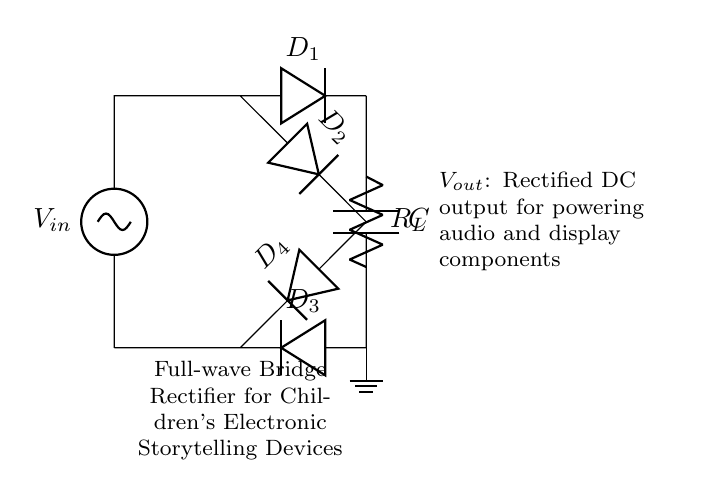What is the type of rectifier used in this circuit? The circuit uses a full-wave bridge rectifier, which is evident from the arrangement of four diodes configured to allow both halves of the AC waveform to contribute to the output.
Answer: full-wave bridge rectifier How many diodes are present in this circuit? There are four diodes in the circuit, labeled as D1, D2, D3, and D4, all crucial for the full-wave rectification process.
Answer: four What is the role of the capacitor in this circuit? The capacitor, labeled as C, is used for smoothing the rectified output. It charges during the peaks of the voltage and discharges to maintain a consistent DC voltage level.
Answer: smoothing What is the output of this rectifier circuit used for? The output, denoted as Vout, is specifically intended to power audio and display components in children's electronic storytelling devices.
Answer: powering audio and display components In which direction do the diodes conduct during the positive half cycle? During the positive half cycle of the AC input, D1 and D2 conduct, allowing current to flow through the load in the forward direction.
Answer: D1 and D2 Which component acts as the load in this circuit? The resistor labeled as R_L acts as the load, utilizing the rectified current to power the device's functions.
Answer: resistor What is the significance of using a bridge rectifier instead of a center-tap rectifier? A bridge rectifier allows for full-wave rectification without the need for a center-tapped transformer, making the circuit simpler and more compact, which is advantageous for children's electronic devices.
Answer: more compact circuit 